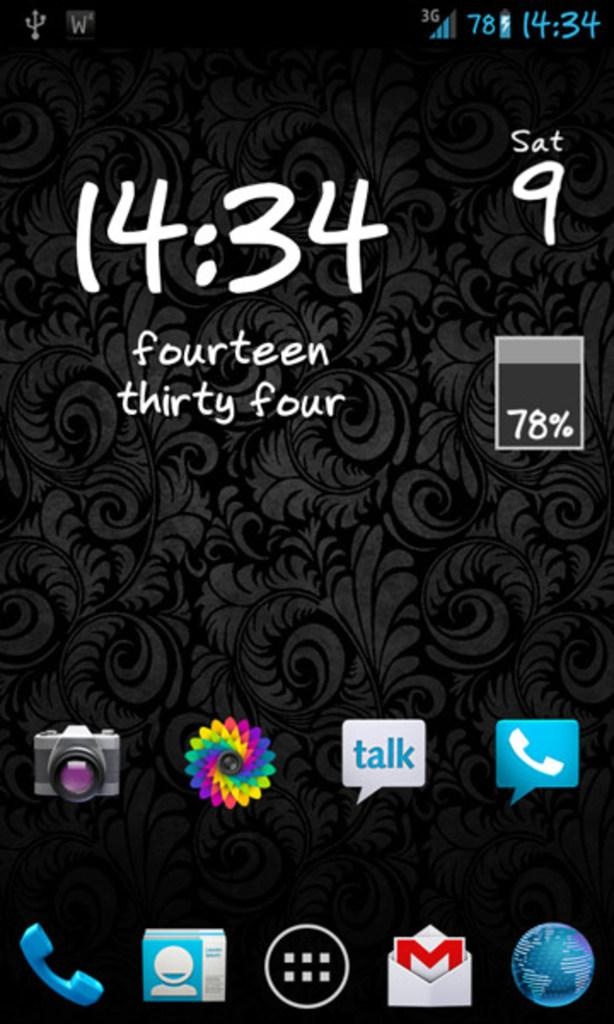<image>
Offer a succinct explanation of the picture presented. A phone screen shows the battery charge level at 78%. 